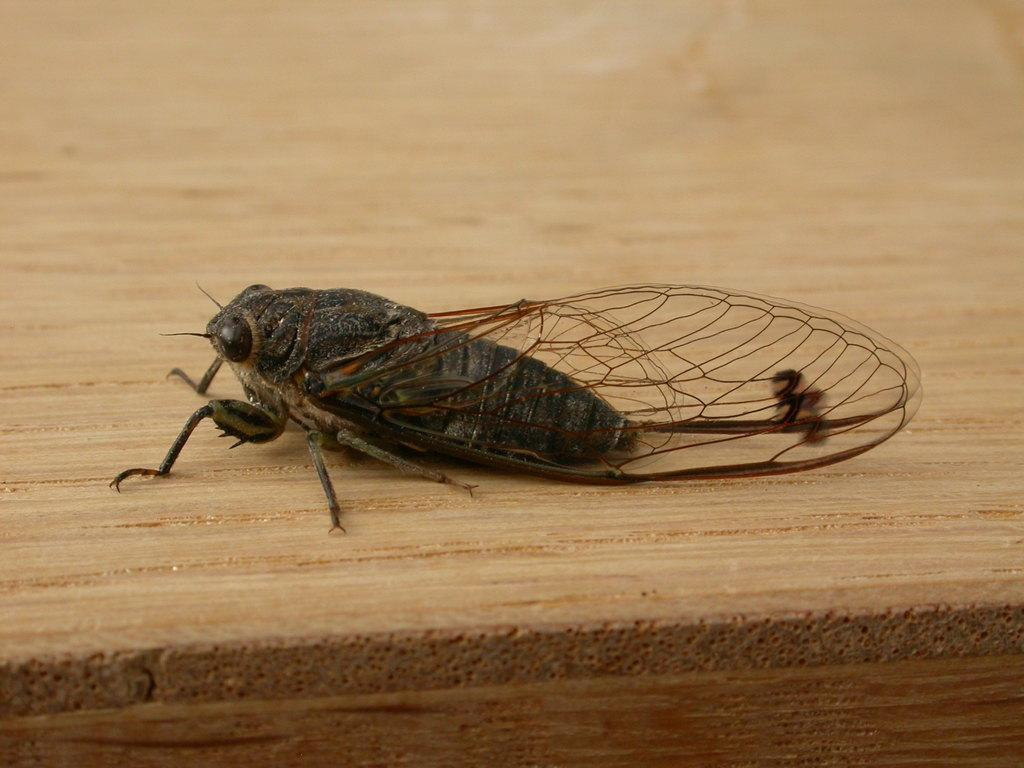What type of creature is present in the image? There is an insect in the image. Where is the insect located? The insect is on a wooden board. What type of crime is being committed by the insect in the image? There is no crime being committed by the insect in the image, as insects do not engage in criminal activities. 